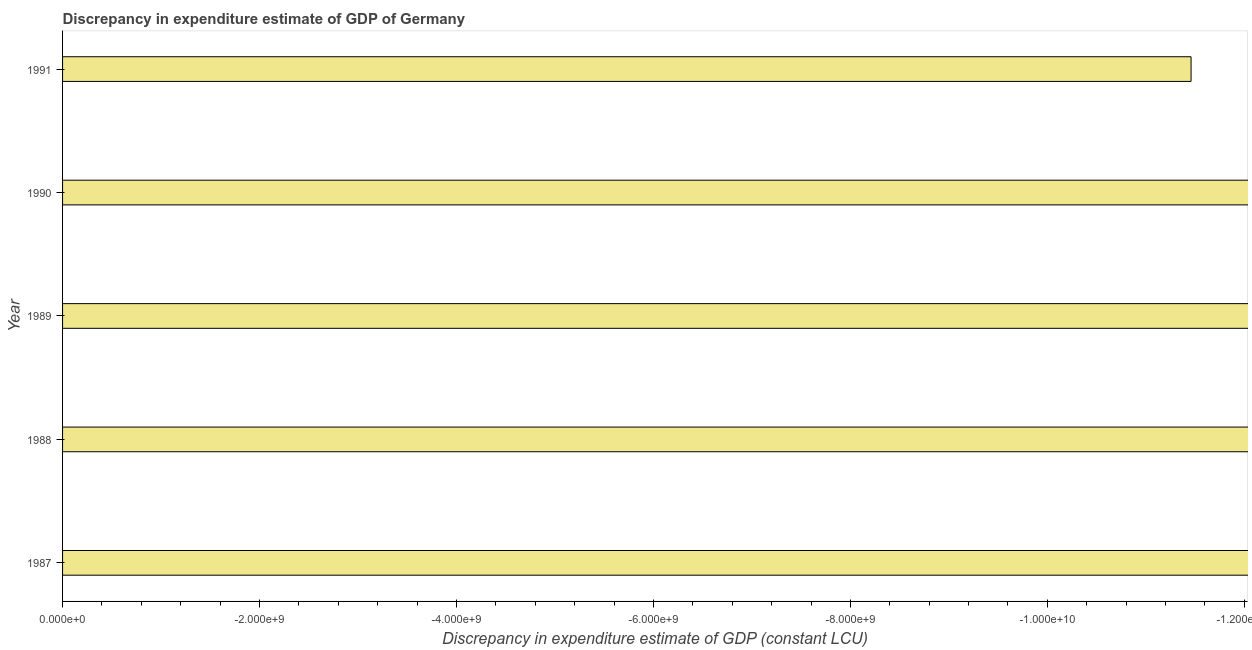Does the graph contain any zero values?
Offer a very short reply. Yes. What is the title of the graph?
Make the answer very short. Discrepancy in expenditure estimate of GDP of Germany. What is the label or title of the X-axis?
Offer a terse response. Discrepancy in expenditure estimate of GDP (constant LCU). What is the discrepancy in expenditure estimate of gdp in 1988?
Provide a succinct answer. 0. What is the sum of the discrepancy in expenditure estimate of gdp?
Your answer should be compact. 0. What is the difference between two consecutive major ticks on the X-axis?
Give a very brief answer. 2.00e+09. What is the Discrepancy in expenditure estimate of GDP (constant LCU) in 1987?
Offer a terse response. 0. What is the Discrepancy in expenditure estimate of GDP (constant LCU) in 1988?
Your answer should be compact. 0. 